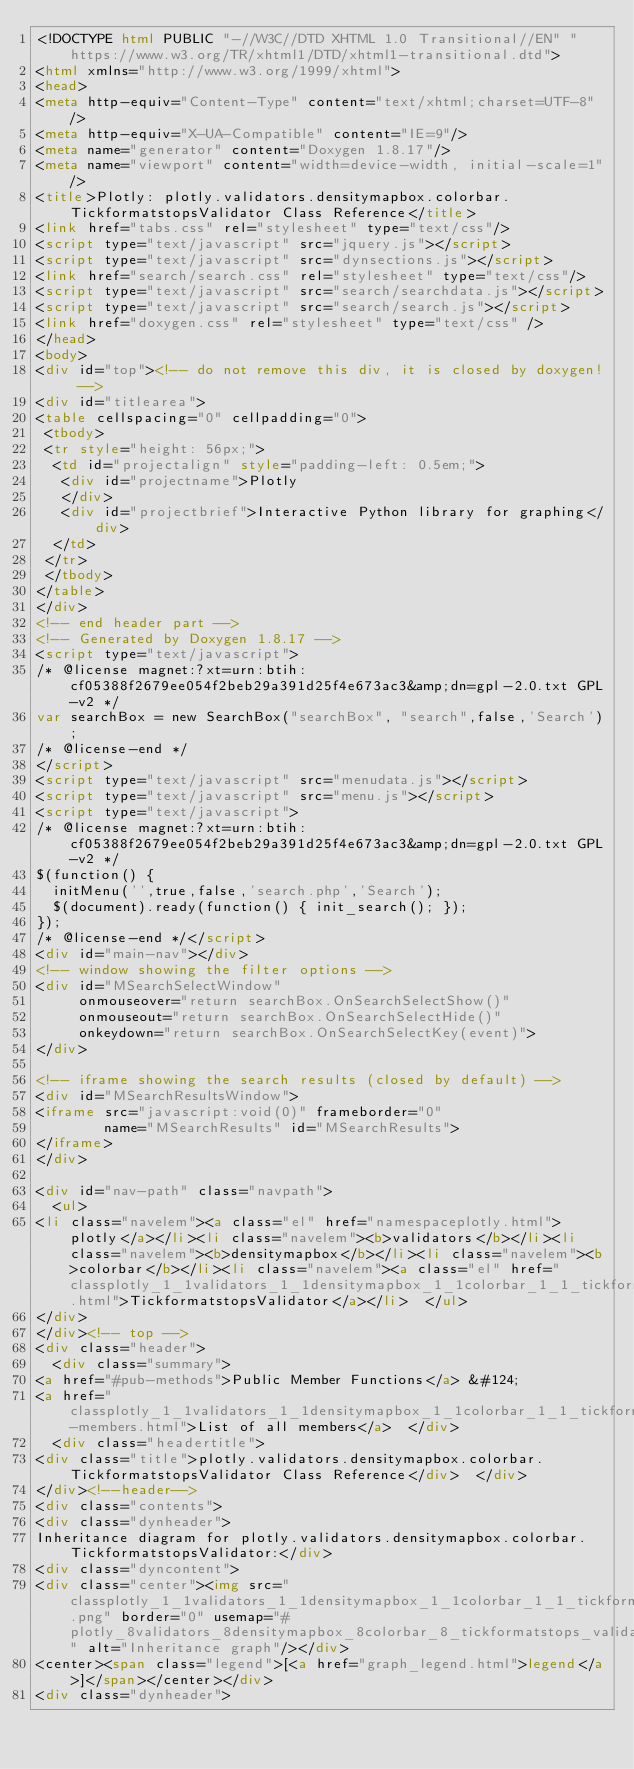<code> <loc_0><loc_0><loc_500><loc_500><_HTML_><!DOCTYPE html PUBLIC "-//W3C//DTD XHTML 1.0 Transitional//EN" "https://www.w3.org/TR/xhtml1/DTD/xhtml1-transitional.dtd">
<html xmlns="http://www.w3.org/1999/xhtml">
<head>
<meta http-equiv="Content-Type" content="text/xhtml;charset=UTF-8"/>
<meta http-equiv="X-UA-Compatible" content="IE=9"/>
<meta name="generator" content="Doxygen 1.8.17"/>
<meta name="viewport" content="width=device-width, initial-scale=1"/>
<title>Plotly: plotly.validators.densitymapbox.colorbar.TickformatstopsValidator Class Reference</title>
<link href="tabs.css" rel="stylesheet" type="text/css"/>
<script type="text/javascript" src="jquery.js"></script>
<script type="text/javascript" src="dynsections.js"></script>
<link href="search/search.css" rel="stylesheet" type="text/css"/>
<script type="text/javascript" src="search/searchdata.js"></script>
<script type="text/javascript" src="search/search.js"></script>
<link href="doxygen.css" rel="stylesheet" type="text/css" />
</head>
<body>
<div id="top"><!-- do not remove this div, it is closed by doxygen! -->
<div id="titlearea">
<table cellspacing="0" cellpadding="0">
 <tbody>
 <tr style="height: 56px;">
  <td id="projectalign" style="padding-left: 0.5em;">
   <div id="projectname">Plotly
   </div>
   <div id="projectbrief">Interactive Python library for graphing</div>
  </td>
 </tr>
 </tbody>
</table>
</div>
<!-- end header part -->
<!-- Generated by Doxygen 1.8.17 -->
<script type="text/javascript">
/* @license magnet:?xt=urn:btih:cf05388f2679ee054f2beb29a391d25f4e673ac3&amp;dn=gpl-2.0.txt GPL-v2 */
var searchBox = new SearchBox("searchBox", "search",false,'Search');
/* @license-end */
</script>
<script type="text/javascript" src="menudata.js"></script>
<script type="text/javascript" src="menu.js"></script>
<script type="text/javascript">
/* @license magnet:?xt=urn:btih:cf05388f2679ee054f2beb29a391d25f4e673ac3&amp;dn=gpl-2.0.txt GPL-v2 */
$(function() {
  initMenu('',true,false,'search.php','Search');
  $(document).ready(function() { init_search(); });
});
/* @license-end */</script>
<div id="main-nav"></div>
<!-- window showing the filter options -->
<div id="MSearchSelectWindow"
     onmouseover="return searchBox.OnSearchSelectShow()"
     onmouseout="return searchBox.OnSearchSelectHide()"
     onkeydown="return searchBox.OnSearchSelectKey(event)">
</div>

<!-- iframe showing the search results (closed by default) -->
<div id="MSearchResultsWindow">
<iframe src="javascript:void(0)" frameborder="0" 
        name="MSearchResults" id="MSearchResults">
</iframe>
</div>

<div id="nav-path" class="navpath">
  <ul>
<li class="navelem"><a class="el" href="namespaceplotly.html">plotly</a></li><li class="navelem"><b>validators</b></li><li class="navelem"><b>densitymapbox</b></li><li class="navelem"><b>colorbar</b></li><li class="navelem"><a class="el" href="classplotly_1_1validators_1_1densitymapbox_1_1colorbar_1_1_tickformatstops_validator.html">TickformatstopsValidator</a></li>  </ul>
</div>
</div><!-- top -->
<div class="header">
  <div class="summary">
<a href="#pub-methods">Public Member Functions</a> &#124;
<a href="classplotly_1_1validators_1_1densitymapbox_1_1colorbar_1_1_tickformatstops_validator-members.html">List of all members</a>  </div>
  <div class="headertitle">
<div class="title">plotly.validators.densitymapbox.colorbar.TickformatstopsValidator Class Reference</div>  </div>
</div><!--header-->
<div class="contents">
<div class="dynheader">
Inheritance diagram for plotly.validators.densitymapbox.colorbar.TickformatstopsValidator:</div>
<div class="dyncontent">
<div class="center"><img src="classplotly_1_1validators_1_1densitymapbox_1_1colorbar_1_1_tickformatstops_validator__inherit__graph.png" border="0" usemap="#plotly_8validators_8densitymapbox_8colorbar_8_tickformatstops_validator_inherit__map" alt="Inheritance graph"/></div>
<center><span class="legend">[<a href="graph_legend.html">legend</a>]</span></center></div>
<div class="dynheader"></code> 